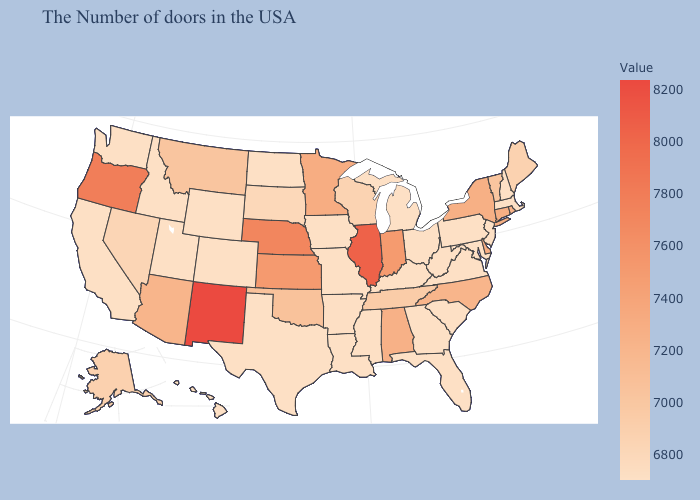Among the states that border Michigan , which have the lowest value?
Short answer required. Ohio. Does Michigan have the lowest value in the MidWest?
Answer briefly. Yes. Does Nevada have the lowest value in the West?
Concise answer only. No. 